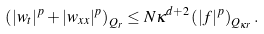Convert formula to latex. <formula><loc_0><loc_0><loc_500><loc_500>\left ( | w _ { t } | ^ { p } + | w _ { x x } | ^ { p } \right ) _ { Q _ { r } } \leq N \kappa ^ { d + 2 } \left ( | f | ^ { p } \right ) _ { Q _ { \kappa r } } .</formula> 